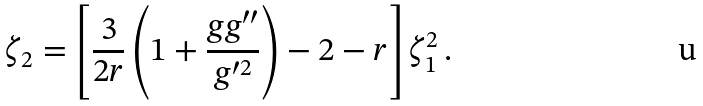<formula> <loc_0><loc_0><loc_500><loc_500>\zeta _ { 2 } = \left [ \frac { 3 } { 2 r } \left ( 1 + \frac { g g ^ { \prime \prime } } { g ^ { \prime 2 } } \right ) - 2 - r \right ] \zeta _ { 1 } ^ { 2 } \, .</formula> 